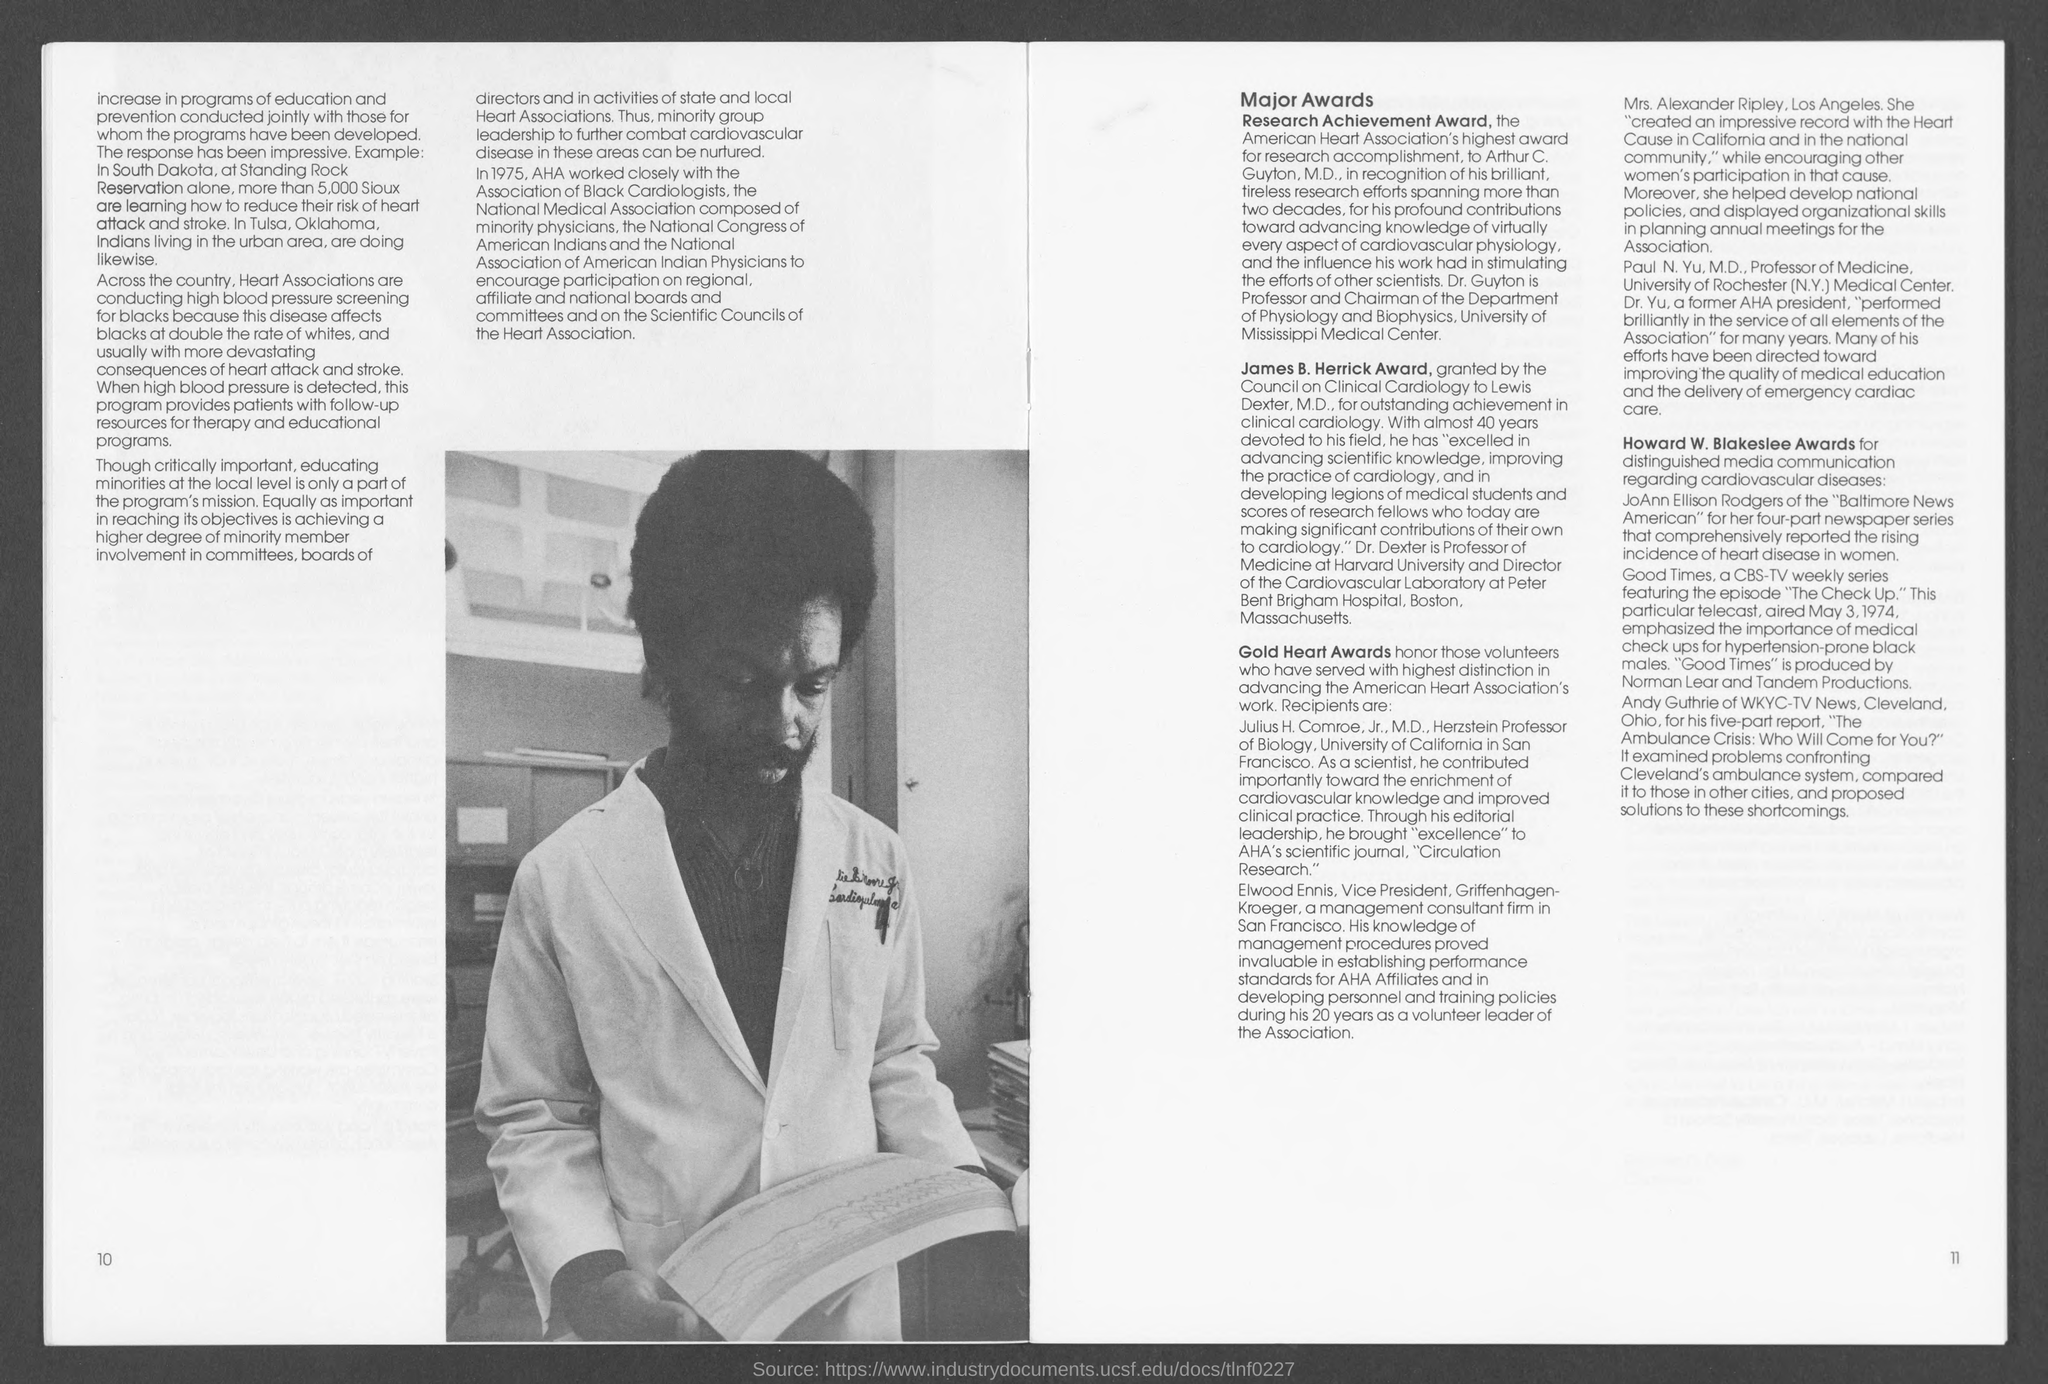What is the deisgnation of Arthur C. Guyton, M.D.?
Keep it short and to the point. Professor and Chairman of the Department of Physiology and Biophysics, University of Mississippi Medical Center. Which award honor those volunteers who have served with highest distinction in advancing the AHA's work?
Keep it short and to the point. Gold Heart Awards. Who is the Herzstein Professor of Biology, University of California in San Francisco?
Keep it short and to the point. Julius H. Comroe, Jr., M.D.,. Which award is granted for distinguished media communication regarding cardiovascular diseases?
Keep it short and to the point. Howard W. Blakeslee Awards. Who created an impressive record with the Heart Cause in California and in the national community?
Offer a terse response. Mrs. Alexander Ripley, Los Angeles. 